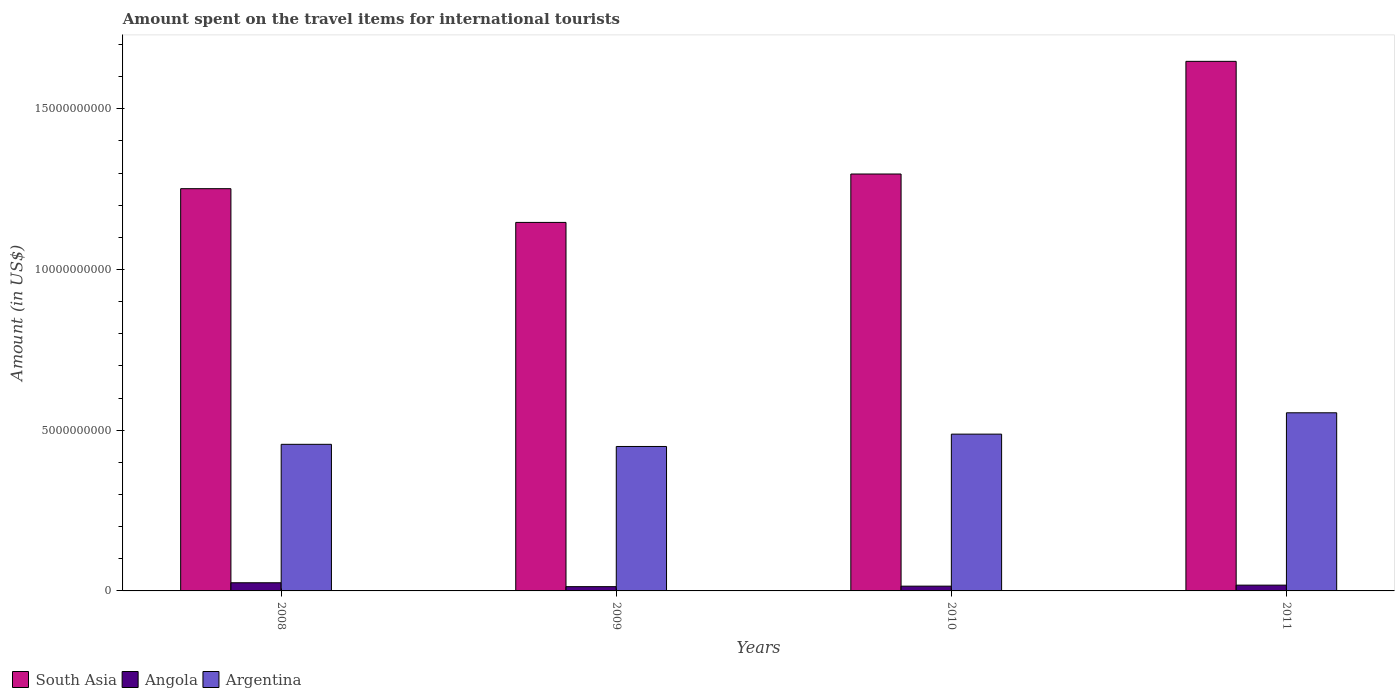How many groups of bars are there?
Provide a short and direct response. 4. Are the number of bars on each tick of the X-axis equal?
Offer a terse response. Yes. How many bars are there on the 3rd tick from the left?
Provide a succinct answer. 3. In how many cases, is the number of bars for a given year not equal to the number of legend labels?
Provide a short and direct response. 0. What is the amount spent on the travel items for international tourists in South Asia in 2010?
Your answer should be compact. 1.30e+1. Across all years, what is the maximum amount spent on the travel items for international tourists in Argentina?
Offer a terse response. 5.54e+09. Across all years, what is the minimum amount spent on the travel items for international tourists in South Asia?
Your response must be concise. 1.15e+1. What is the total amount spent on the travel items for international tourists in Angola in the graph?
Your answer should be compact. 7.15e+08. What is the difference between the amount spent on the travel items for international tourists in Angola in 2008 and that in 2009?
Your response must be concise. 1.21e+08. What is the difference between the amount spent on the travel items for international tourists in Argentina in 2011 and the amount spent on the travel items for international tourists in South Asia in 2010?
Keep it short and to the point. -7.43e+09. What is the average amount spent on the travel items for international tourists in Angola per year?
Keep it short and to the point. 1.79e+08. In the year 2010, what is the difference between the amount spent on the travel items for international tourists in Argentina and amount spent on the travel items for international tourists in Angola?
Ensure brevity in your answer.  4.73e+09. What is the ratio of the amount spent on the travel items for international tourists in South Asia in 2009 to that in 2010?
Keep it short and to the point. 0.88. What is the difference between the highest and the second highest amount spent on the travel items for international tourists in South Asia?
Your response must be concise. 3.50e+09. What is the difference between the highest and the lowest amount spent on the travel items for international tourists in Argentina?
Make the answer very short. 1.05e+09. In how many years, is the amount spent on the travel items for international tourists in South Asia greater than the average amount spent on the travel items for international tourists in South Asia taken over all years?
Your answer should be compact. 1. Is the sum of the amount spent on the travel items for international tourists in Argentina in 2008 and 2010 greater than the maximum amount spent on the travel items for international tourists in South Asia across all years?
Your response must be concise. No. Is it the case that in every year, the sum of the amount spent on the travel items for international tourists in Argentina and amount spent on the travel items for international tourists in South Asia is greater than the amount spent on the travel items for international tourists in Angola?
Offer a terse response. Yes. Are all the bars in the graph horizontal?
Your answer should be compact. No. What is the difference between two consecutive major ticks on the Y-axis?
Provide a short and direct response. 5.00e+09. Are the values on the major ticks of Y-axis written in scientific E-notation?
Your answer should be very brief. No. Does the graph contain grids?
Provide a short and direct response. No. How many legend labels are there?
Make the answer very short. 3. How are the legend labels stacked?
Make the answer very short. Horizontal. What is the title of the graph?
Ensure brevity in your answer.  Amount spent on the travel items for international tourists. What is the label or title of the X-axis?
Your answer should be compact. Years. What is the Amount (in US$) of South Asia in 2008?
Your answer should be very brief. 1.25e+1. What is the Amount (in US$) in Angola in 2008?
Your answer should be very brief. 2.54e+08. What is the Amount (in US$) in Argentina in 2008?
Offer a terse response. 4.56e+09. What is the Amount (in US$) in South Asia in 2009?
Your response must be concise. 1.15e+1. What is the Amount (in US$) of Angola in 2009?
Give a very brief answer. 1.33e+08. What is the Amount (in US$) in Argentina in 2009?
Your response must be concise. 4.49e+09. What is the Amount (in US$) of South Asia in 2010?
Your answer should be compact. 1.30e+1. What is the Amount (in US$) in Angola in 2010?
Give a very brief answer. 1.48e+08. What is the Amount (in US$) of Argentina in 2010?
Your answer should be very brief. 4.88e+09. What is the Amount (in US$) in South Asia in 2011?
Keep it short and to the point. 1.65e+1. What is the Amount (in US$) in Angola in 2011?
Your answer should be very brief. 1.80e+08. What is the Amount (in US$) of Argentina in 2011?
Keep it short and to the point. 5.54e+09. Across all years, what is the maximum Amount (in US$) of South Asia?
Offer a very short reply. 1.65e+1. Across all years, what is the maximum Amount (in US$) in Angola?
Offer a very short reply. 2.54e+08. Across all years, what is the maximum Amount (in US$) of Argentina?
Provide a short and direct response. 5.54e+09. Across all years, what is the minimum Amount (in US$) of South Asia?
Ensure brevity in your answer.  1.15e+1. Across all years, what is the minimum Amount (in US$) in Angola?
Your response must be concise. 1.33e+08. Across all years, what is the minimum Amount (in US$) in Argentina?
Your answer should be compact. 4.49e+09. What is the total Amount (in US$) in South Asia in the graph?
Offer a terse response. 5.34e+1. What is the total Amount (in US$) in Angola in the graph?
Your answer should be compact. 7.15e+08. What is the total Amount (in US$) in Argentina in the graph?
Offer a terse response. 1.95e+1. What is the difference between the Amount (in US$) of South Asia in 2008 and that in 2009?
Keep it short and to the point. 1.05e+09. What is the difference between the Amount (in US$) in Angola in 2008 and that in 2009?
Provide a short and direct response. 1.21e+08. What is the difference between the Amount (in US$) of Argentina in 2008 and that in 2009?
Offer a very short reply. 6.70e+07. What is the difference between the Amount (in US$) of South Asia in 2008 and that in 2010?
Your answer should be compact. -4.57e+08. What is the difference between the Amount (in US$) of Angola in 2008 and that in 2010?
Offer a very short reply. 1.06e+08. What is the difference between the Amount (in US$) of Argentina in 2008 and that in 2010?
Provide a short and direct response. -3.17e+08. What is the difference between the Amount (in US$) in South Asia in 2008 and that in 2011?
Offer a terse response. -3.96e+09. What is the difference between the Amount (in US$) in Angola in 2008 and that in 2011?
Your answer should be very brief. 7.40e+07. What is the difference between the Amount (in US$) in Argentina in 2008 and that in 2011?
Your answer should be compact. -9.81e+08. What is the difference between the Amount (in US$) in South Asia in 2009 and that in 2010?
Ensure brevity in your answer.  -1.51e+09. What is the difference between the Amount (in US$) in Angola in 2009 and that in 2010?
Your response must be concise. -1.50e+07. What is the difference between the Amount (in US$) in Argentina in 2009 and that in 2010?
Your answer should be very brief. -3.84e+08. What is the difference between the Amount (in US$) in South Asia in 2009 and that in 2011?
Your answer should be very brief. -5.01e+09. What is the difference between the Amount (in US$) in Angola in 2009 and that in 2011?
Your answer should be compact. -4.70e+07. What is the difference between the Amount (in US$) in Argentina in 2009 and that in 2011?
Offer a terse response. -1.05e+09. What is the difference between the Amount (in US$) of South Asia in 2010 and that in 2011?
Make the answer very short. -3.50e+09. What is the difference between the Amount (in US$) in Angola in 2010 and that in 2011?
Ensure brevity in your answer.  -3.20e+07. What is the difference between the Amount (in US$) in Argentina in 2010 and that in 2011?
Provide a succinct answer. -6.64e+08. What is the difference between the Amount (in US$) in South Asia in 2008 and the Amount (in US$) in Angola in 2009?
Offer a very short reply. 1.24e+1. What is the difference between the Amount (in US$) of South Asia in 2008 and the Amount (in US$) of Argentina in 2009?
Offer a terse response. 8.02e+09. What is the difference between the Amount (in US$) in Angola in 2008 and the Amount (in US$) in Argentina in 2009?
Provide a short and direct response. -4.24e+09. What is the difference between the Amount (in US$) of South Asia in 2008 and the Amount (in US$) of Angola in 2010?
Your answer should be very brief. 1.24e+1. What is the difference between the Amount (in US$) in South Asia in 2008 and the Amount (in US$) in Argentina in 2010?
Your answer should be very brief. 7.64e+09. What is the difference between the Amount (in US$) of Angola in 2008 and the Amount (in US$) of Argentina in 2010?
Keep it short and to the point. -4.62e+09. What is the difference between the Amount (in US$) in South Asia in 2008 and the Amount (in US$) in Angola in 2011?
Provide a short and direct response. 1.23e+1. What is the difference between the Amount (in US$) of South Asia in 2008 and the Amount (in US$) of Argentina in 2011?
Give a very brief answer. 6.97e+09. What is the difference between the Amount (in US$) in Angola in 2008 and the Amount (in US$) in Argentina in 2011?
Provide a short and direct response. -5.29e+09. What is the difference between the Amount (in US$) of South Asia in 2009 and the Amount (in US$) of Angola in 2010?
Offer a very short reply. 1.13e+1. What is the difference between the Amount (in US$) in South Asia in 2009 and the Amount (in US$) in Argentina in 2010?
Provide a short and direct response. 6.59e+09. What is the difference between the Amount (in US$) of Angola in 2009 and the Amount (in US$) of Argentina in 2010?
Keep it short and to the point. -4.74e+09. What is the difference between the Amount (in US$) of South Asia in 2009 and the Amount (in US$) of Angola in 2011?
Offer a terse response. 1.13e+1. What is the difference between the Amount (in US$) of South Asia in 2009 and the Amount (in US$) of Argentina in 2011?
Give a very brief answer. 5.92e+09. What is the difference between the Amount (in US$) in Angola in 2009 and the Amount (in US$) in Argentina in 2011?
Ensure brevity in your answer.  -5.41e+09. What is the difference between the Amount (in US$) in South Asia in 2010 and the Amount (in US$) in Angola in 2011?
Provide a succinct answer. 1.28e+1. What is the difference between the Amount (in US$) in South Asia in 2010 and the Amount (in US$) in Argentina in 2011?
Ensure brevity in your answer.  7.43e+09. What is the difference between the Amount (in US$) of Angola in 2010 and the Amount (in US$) of Argentina in 2011?
Offer a terse response. -5.39e+09. What is the average Amount (in US$) in South Asia per year?
Provide a short and direct response. 1.34e+1. What is the average Amount (in US$) in Angola per year?
Your response must be concise. 1.79e+08. What is the average Amount (in US$) in Argentina per year?
Provide a short and direct response. 4.87e+09. In the year 2008, what is the difference between the Amount (in US$) of South Asia and Amount (in US$) of Angola?
Offer a very short reply. 1.23e+1. In the year 2008, what is the difference between the Amount (in US$) in South Asia and Amount (in US$) in Argentina?
Give a very brief answer. 7.95e+09. In the year 2008, what is the difference between the Amount (in US$) in Angola and Amount (in US$) in Argentina?
Provide a short and direct response. -4.31e+09. In the year 2009, what is the difference between the Amount (in US$) of South Asia and Amount (in US$) of Angola?
Your answer should be compact. 1.13e+1. In the year 2009, what is the difference between the Amount (in US$) in South Asia and Amount (in US$) in Argentina?
Offer a terse response. 6.97e+09. In the year 2009, what is the difference between the Amount (in US$) in Angola and Amount (in US$) in Argentina?
Provide a short and direct response. -4.36e+09. In the year 2010, what is the difference between the Amount (in US$) in South Asia and Amount (in US$) in Angola?
Make the answer very short. 1.28e+1. In the year 2010, what is the difference between the Amount (in US$) of South Asia and Amount (in US$) of Argentina?
Provide a succinct answer. 8.09e+09. In the year 2010, what is the difference between the Amount (in US$) of Angola and Amount (in US$) of Argentina?
Provide a succinct answer. -4.73e+09. In the year 2011, what is the difference between the Amount (in US$) in South Asia and Amount (in US$) in Angola?
Ensure brevity in your answer.  1.63e+1. In the year 2011, what is the difference between the Amount (in US$) in South Asia and Amount (in US$) in Argentina?
Offer a very short reply. 1.09e+1. In the year 2011, what is the difference between the Amount (in US$) of Angola and Amount (in US$) of Argentina?
Provide a succinct answer. -5.36e+09. What is the ratio of the Amount (in US$) in South Asia in 2008 to that in 2009?
Ensure brevity in your answer.  1.09. What is the ratio of the Amount (in US$) in Angola in 2008 to that in 2009?
Give a very brief answer. 1.91. What is the ratio of the Amount (in US$) of Argentina in 2008 to that in 2009?
Keep it short and to the point. 1.01. What is the ratio of the Amount (in US$) in South Asia in 2008 to that in 2010?
Give a very brief answer. 0.96. What is the ratio of the Amount (in US$) of Angola in 2008 to that in 2010?
Offer a terse response. 1.72. What is the ratio of the Amount (in US$) of Argentina in 2008 to that in 2010?
Provide a succinct answer. 0.94. What is the ratio of the Amount (in US$) of South Asia in 2008 to that in 2011?
Your response must be concise. 0.76. What is the ratio of the Amount (in US$) in Angola in 2008 to that in 2011?
Your response must be concise. 1.41. What is the ratio of the Amount (in US$) of Argentina in 2008 to that in 2011?
Make the answer very short. 0.82. What is the ratio of the Amount (in US$) of South Asia in 2009 to that in 2010?
Your answer should be very brief. 0.88. What is the ratio of the Amount (in US$) in Angola in 2009 to that in 2010?
Offer a terse response. 0.9. What is the ratio of the Amount (in US$) of Argentina in 2009 to that in 2010?
Offer a terse response. 0.92. What is the ratio of the Amount (in US$) of South Asia in 2009 to that in 2011?
Give a very brief answer. 0.7. What is the ratio of the Amount (in US$) of Angola in 2009 to that in 2011?
Give a very brief answer. 0.74. What is the ratio of the Amount (in US$) in Argentina in 2009 to that in 2011?
Give a very brief answer. 0.81. What is the ratio of the Amount (in US$) of South Asia in 2010 to that in 2011?
Give a very brief answer. 0.79. What is the ratio of the Amount (in US$) in Angola in 2010 to that in 2011?
Offer a terse response. 0.82. What is the ratio of the Amount (in US$) in Argentina in 2010 to that in 2011?
Provide a succinct answer. 0.88. What is the difference between the highest and the second highest Amount (in US$) in South Asia?
Your answer should be very brief. 3.50e+09. What is the difference between the highest and the second highest Amount (in US$) of Angola?
Your answer should be very brief. 7.40e+07. What is the difference between the highest and the second highest Amount (in US$) of Argentina?
Keep it short and to the point. 6.64e+08. What is the difference between the highest and the lowest Amount (in US$) of South Asia?
Offer a very short reply. 5.01e+09. What is the difference between the highest and the lowest Amount (in US$) of Angola?
Give a very brief answer. 1.21e+08. What is the difference between the highest and the lowest Amount (in US$) in Argentina?
Ensure brevity in your answer.  1.05e+09. 